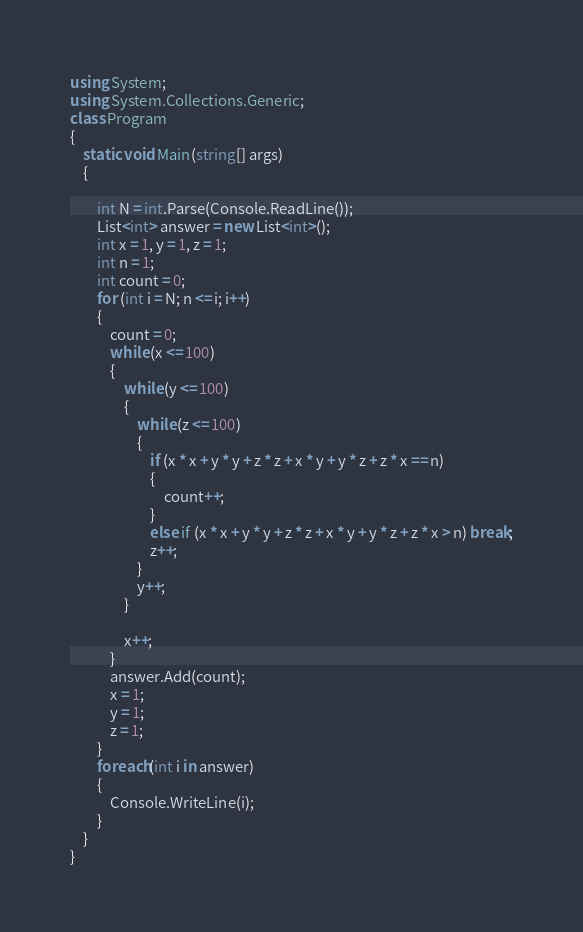<code> <loc_0><loc_0><loc_500><loc_500><_C#_>using System;
using System.Collections.Generic;
class Program
{
    static void Main(string[] args)
    {

        int N = int.Parse(Console.ReadLine());
        List<int> answer = new List<int>();
        int x = 1, y = 1, z = 1;
        int n = 1;
        int count = 0;
        for (int i = N; n <= i; i++)
        {
            count = 0;
            while (x <= 100)
            {
                while (y <= 100)
                {
                    while (z <= 100)
                    {
                        if (x * x + y * y + z * z + x * y + y * z + z * x == n)
                        {
                            count++;
                        }
                        else if (x * x + y * y + z * z + x * y + y * z + z * x > n) break;
                        z++;
                    }
                    y++;
                }

                x++;
            }
            answer.Add(count);
            x = 1;
            y = 1;
            z = 1;
        }
        foreach(int i in answer)
        {
            Console.WriteLine(i);
        }
    }
}
</code> 